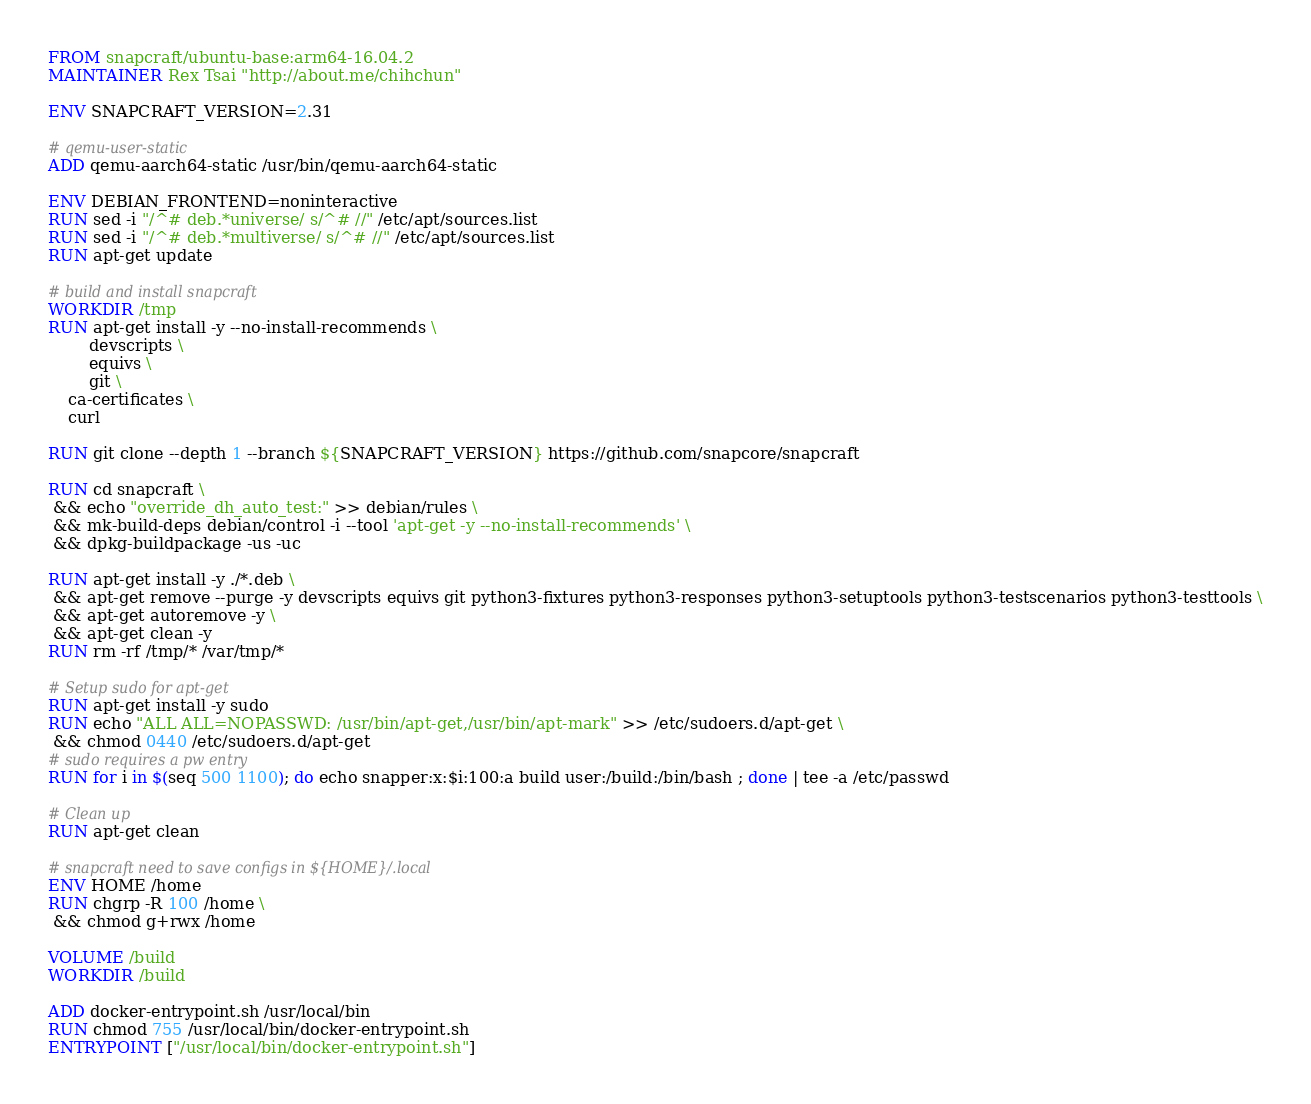Convert code to text. <code><loc_0><loc_0><loc_500><loc_500><_Dockerfile_>FROM snapcraft/ubuntu-base:arm64-16.04.2
MAINTAINER Rex Tsai "http://about.me/chihchun"

ENV SNAPCRAFT_VERSION=2.31

# qemu-user-static
ADD qemu-aarch64-static /usr/bin/qemu-aarch64-static

ENV DEBIAN_FRONTEND=noninteractive
RUN sed -i "/^# deb.*universe/ s/^# //" /etc/apt/sources.list
RUN sed -i "/^# deb.*multiverse/ s/^# //" /etc/apt/sources.list
RUN apt-get update

# build and install snapcraft
WORKDIR /tmp
RUN apt-get install -y --no-install-recommends \
        devscripts \
        equivs \
        git \
	ca-certificates \
	curl

RUN git clone --depth 1 --branch ${SNAPCRAFT_VERSION} https://github.com/snapcore/snapcraft 

RUN cd snapcraft \
 && echo "override_dh_auto_test:" >> debian/rules \
 && mk-build-deps debian/control -i --tool 'apt-get -y --no-install-recommends' \
 && dpkg-buildpackage -us -uc 

RUN apt-get install -y ./*.deb \
 && apt-get remove --purge -y devscripts equivs git python3-fixtures python3-responses python3-setuptools python3-testscenarios python3-testtools \
 && apt-get autoremove -y \
 && apt-get clean -y
RUN rm -rf /tmp/* /var/tmp/*

# Setup sudo for apt-get
RUN apt-get install -y sudo
RUN echo "ALL ALL=NOPASSWD: /usr/bin/apt-get,/usr/bin/apt-mark" >> /etc/sudoers.d/apt-get \
 && chmod 0440 /etc/sudoers.d/apt-get
# sudo requires a pw entry
RUN for i in $(seq 500 1100); do echo snapper:x:$i:100:a build user:/build:/bin/bash ; done | tee -a /etc/passwd

# Clean up
RUN apt-get clean

# snapcraft need to save configs in ${HOME}/.local
ENV HOME /home
RUN chgrp -R 100 /home \
 && chmod g+rwx /home

VOLUME /build
WORKDIR /build

ADD docker-entrypoint.sh /usr/local/bin
RUN chmod 755 /usr/local/bin/docker-entrypoint.sh
ENTRYPOINT ["/usr/local/bin/docker-entrypoint.sh"]
</code> 